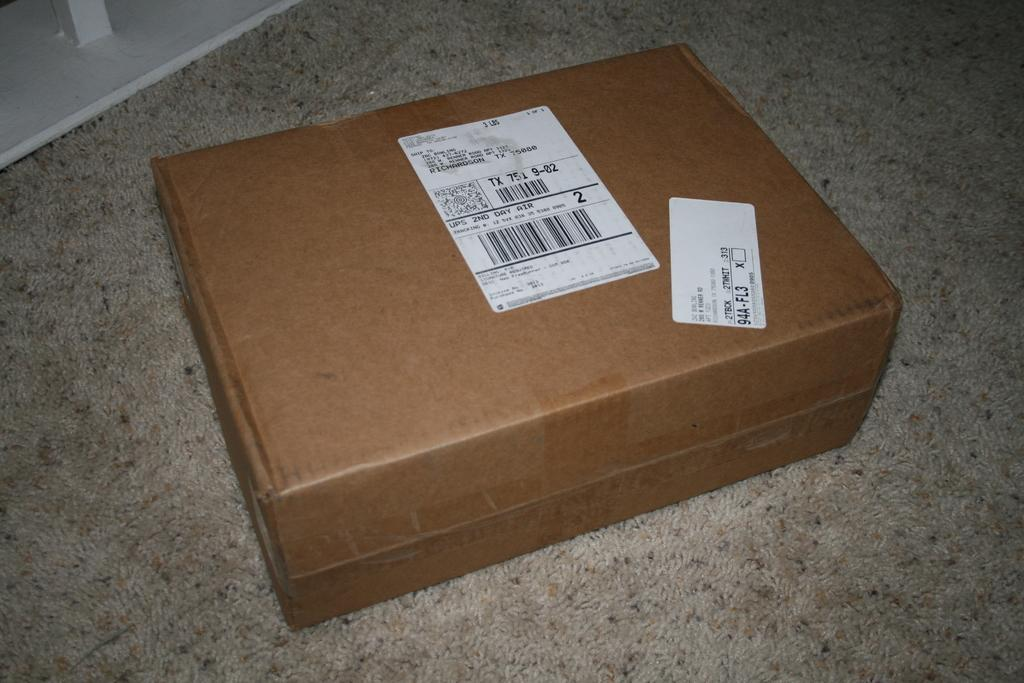<image>
Provide a brief description of the given image. A package that is addressed to Zac Bowlling. 